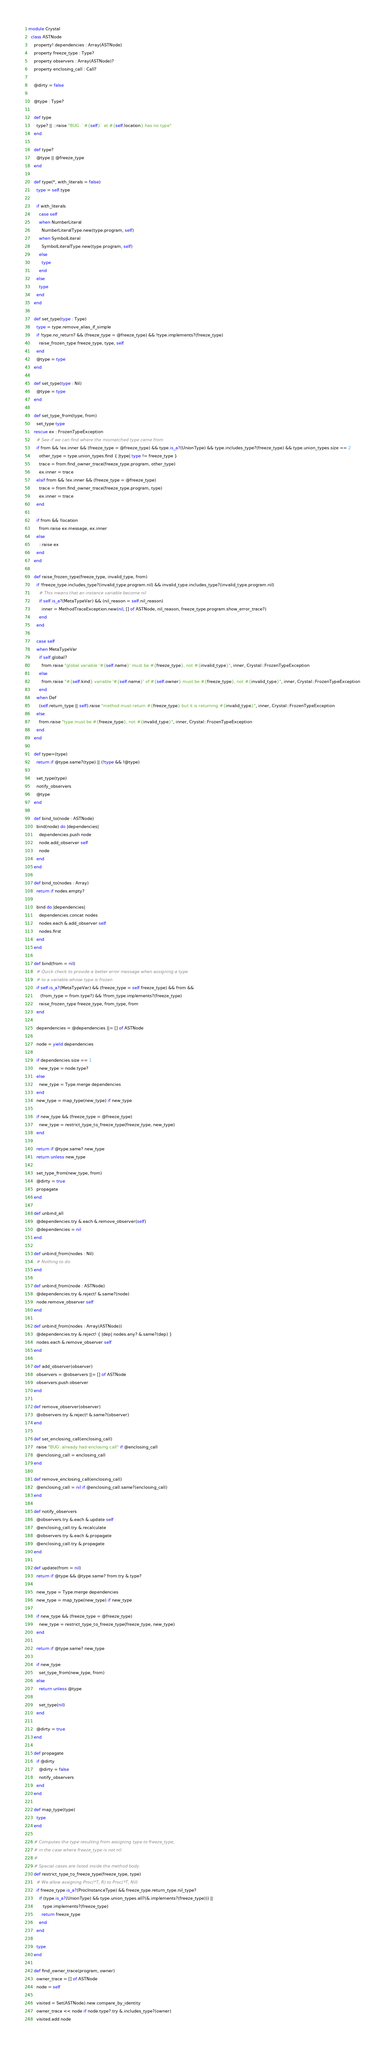<code> <loc_0><loc_0><loc_500><loc_500><_Crystal_>module Crystal
  class ASTNode
    property! dependencies : Array(ASTNode)
    property freeze_type : Type?
    property observers : Array(ASTNode)?
    property enclosing_call : Call?

    @dirty = false

    @type : Type?

    def type
      type? || ::raise "BUG: `#{self}` at #{self.location} has no type"
    end

    def type?
      @type || @freeze_type
    end

    def type(*, with_literals = false)
      type = self.type

      if with_literals
        case self
        when NumberLiteral
          NumberLiteralType.new(type.program, self)
        when SymbolLiteral
          SymbolLiteralType.new(type.program, self)
        else
          type
        end
      else
        type
      end
    end

    def set_type(type : Type)
      type = type.remove_alias_if_simple
      if !type.no_return? && (freeze_type = @freeze_type) && !type.implements?(freeze_type)
        raise_frozen_type freeze_type, type, self
      end
      @type = type
    end

    def set_type(type : Nil)
      @type = type
    end

    def set_type_from(type, from)
      set_type type
    rescue ex : FrozenTypeException
      # See if we can find where the mismatched type came from
      if from && !ex.inner && (freeze_type = @freeze_type) && type.is_a?(UnionType) && type.includes_type?(freeze_type) && type.union_types.size == 2
        other_type = type.union_types.find { |type| type != freeze_type }
        trace = from.find_owner_trace(freeze_type.program, other_type)
        ex.inner = trace
      elsif from && !ex.inner && (freeze_type = @freeze_type)
        trace = from.find_owner_trace(freeze_type.program, type)
        ex.inner = trace
      end

      if from && !location
        from.raise ex.message, ex.inner
      else
        ::raise ex
      end
    end

    def raise_frozen_type(freeze_type, invalid_type, from)
      if !freeze_type.includes_type?(invalid_type.program.nil) && invalid_type.includes_type?(invalid_type.program.nil)
        # This means that an instance variable become nil
        if self.is_a?(MetaTypeVar) && (nil_reason = self.nil_reason)
          inner = MethodTraceException.new(nil, [] of ASTNode, nil_reason, freeze_type.program.show_error_trace?)
        end
      end

      case self
      when MetaTypeVar
        if self.global?
          from.raise "global variable '#{self.name}' must be #{freeze_type}, not #{invalid_type}", inner, Crystal::FrozenTypeException
        else
          from.raise "#{self.kind} variable '#{self.name}' of #{self.owner} must be #{freeze_type}, not #{invalid_type}", inner, Crystal::FrozenTypeException
        end
      when Def
        (self.return_type || self).raise "method must return #{freeze_type} but it is returning #{invalid_type}", inner, Crystal::FrozenTypeException
      else
        from.raise "type must be #{freeze_type}, not #{invalid_type}", inner, Crystal::FrozenTypeException
      end
    end

    def type=(type)
      return if @type.same?(type) || (!type && !@type)

      set_type(type)
      notify_observers
      @type
    end

    def bind_to(node : ASTNode)
      bind(node) do |dependencies|
        dependencies.push node
        node.add_observer self
        node
      end
    end

    def bind_to(nodes : Array)
      return if nodes.empty?

      bind do |dependencies|
        dependencies.concat nodes
        nodes.each &.add_observer self
        nodes.first
      end
    end

    def bind(from = nil)
      # Quick check to provide a better error message when assigning a type
      # to a variable whose type is frozen
      if self.is_a?(MetaTypeVar) && (freeze_type = self.freeze_type) && from &&
         (from_type = from.type?) && !from_type.implements?(freeze_type)
        raise_frozen_type freeze_type, from_type, from
      end

      dependencies = @dependencies ||= [] of ASTNode

      node = yield dependencies

      if dependencies.size == 1
        new_type = node.type?
      else
        new_type = Type.merge dependencies
      end
      new_type = map_type(new_type) if new_type

      if new_type && (freeze_type = @freeze_type)
        new_type = restrict_type_to_freeze_type(freeze_type, new_type)
      end

      return if @type.same? new_type
      return unless new_type

      set_type_from(new_type, from)
      @dirty = true
      propagate
    end

    def unbind_all
      @dependencies.try &.each &.remove_observer(self)
      @dependencies = nil
    end

    def unbind_from(nodes : Nil)
      # Nothing to do
    end

    def unbind_from(node : ASTNode)
      @dependencies.try &.reject! &.same?(node)
      node.remove_observer self
    end

    def unbind_from(nodes : Array(ASTNode))
      @dependencies.try &.reject! { |dep| nodes.any? &.same?(dep) }
      nodes.each &.remove_observer self
    end

    def add_observer(observer)
      observers = @observers ||= [] of ASTNode
      observers.push observer
    end

    def remove_observer(observer)
      @observers.try &.reject! &.same?(observer)
    end

    def set_enclosing_call(enclosing_call)
      raise "BUG: already had enclosing call" if @enclosing_call
      @enclosing_call = enclosing_call
    end

    def remove_enclosing_call(enclosing_call)
      @enclosing_call = nil if @enclosing_call.same?(enclosing_call)
    end

    def notify_observers
      @observers.try &.each &.update self
      @enclosing_call.try &.recalculate
      @observers.try &.each &.propagate
      @enclosing_call.try &.propagate
    end

    def update(from = nil)
      return if @type && @type.same? from.try &.type?

      new_type = Type.merge dependencies
      new_type = map_type(new_type) if new_type

      if new_type && (freeze_type = @freeze_type)
        new_type = restrict_type_to_freeze_type(freeze_type, new_type)
      end

      return if @type.same? new_type

      if new_type
        set_type_from(new_type, from)
      else
        return unless @type

        set_type(nil)
      end

      @dirty = true
    end

    def propagate
      if @dirty
        @dirty = false
        notify_observers
      end
    end

    def map_type(type)
      type
    end

    # Computes the type resulting from assigning type to freeze_type,
    # in the case where freeze_type is not nil.
    #
    # Special cases are listed inside the method body.
    def restrict_type_to_freeze_type(freeze_type, type)
      # We allow assigning Proc(*T, R) to Proc(*T, Nil)
      if freeze_type.is_a?(ProcInstanceType) && freeze_type.return_type.nil_type?
        if (type.is_a?(UnionType) && type.union_types.all?(&.implements?(freeze_type))) ||
           type.implements?(freeze_type)
          return freeze_type
        end
      end

      type
    end

    def find_owner_trace(program, owner)
      owner_trace = [] of ASTNode
      node = self

      visited = Set(ASTNode).new.compare_by_identity
      owner_trace << node if node.type?.try &.includes_type?(owner)
      visited.add node</code> 